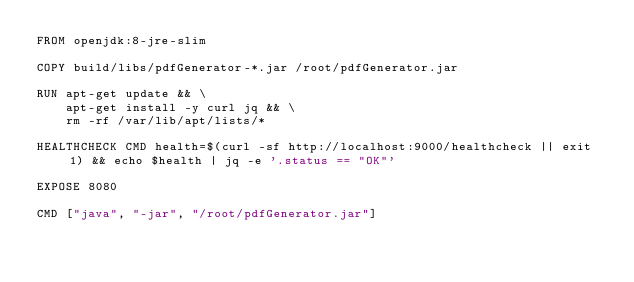<code> <loc_0><loc_0><loc_500><loc_500><_Dockerfile_>FROM openjdk:8-jre-slim

COPY build/libs/pdfGenerator-*.jar /root/pdfGenerator.jar

RUN apt-get update && \
    apt-get install -y curl jq && \
    rm -rf /var/lib/apt/lists/*

HEALTHCHECK CMD health=$(curl -sf http://localhost:9000/healthcheck || exit 1) && echo $health | jq -e '.status == "OK"'

EXPOSE 8080

CMD ["java", "-jar", "/root/pdfGenerator.jar"]
</code> 